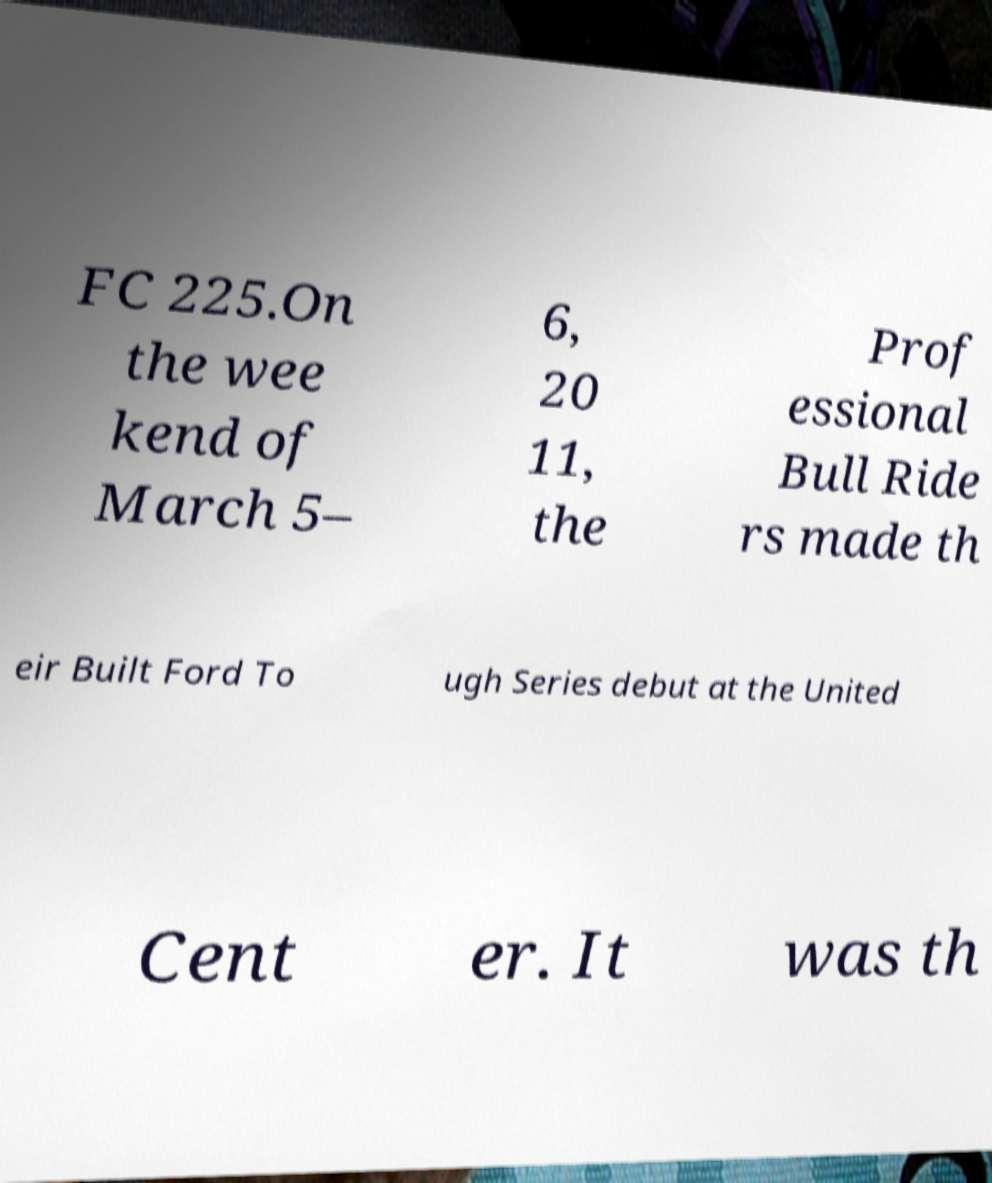I need the written content from this picture converted into text. Can you do that? FC 225.On the wee kend of March 5– 6, 20 11, the Prof essional Bull Ride rs made th eir Built Ford To ugh Series debut at the United Cent er. It was th 